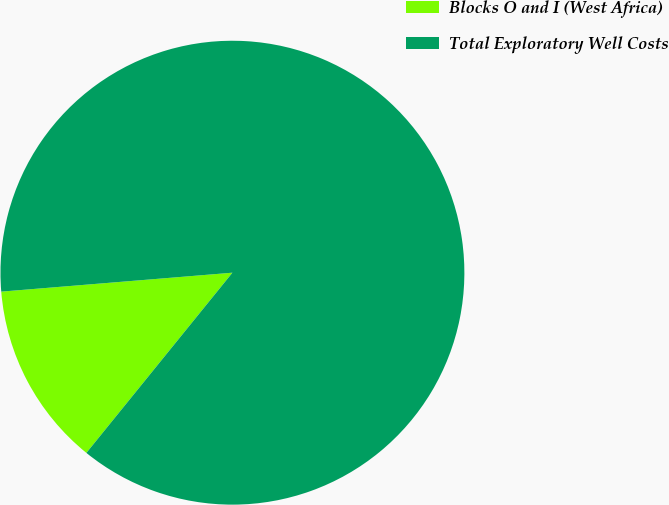<chart> <loc_0><loc_0><loc_500><loc_500><pie_chart><fcel>Blocks O and I (West Africa)<fcel>Total Exploratory Well Costs<nl><fcel>12.86%<fcel>87.14%<nl></chart> 